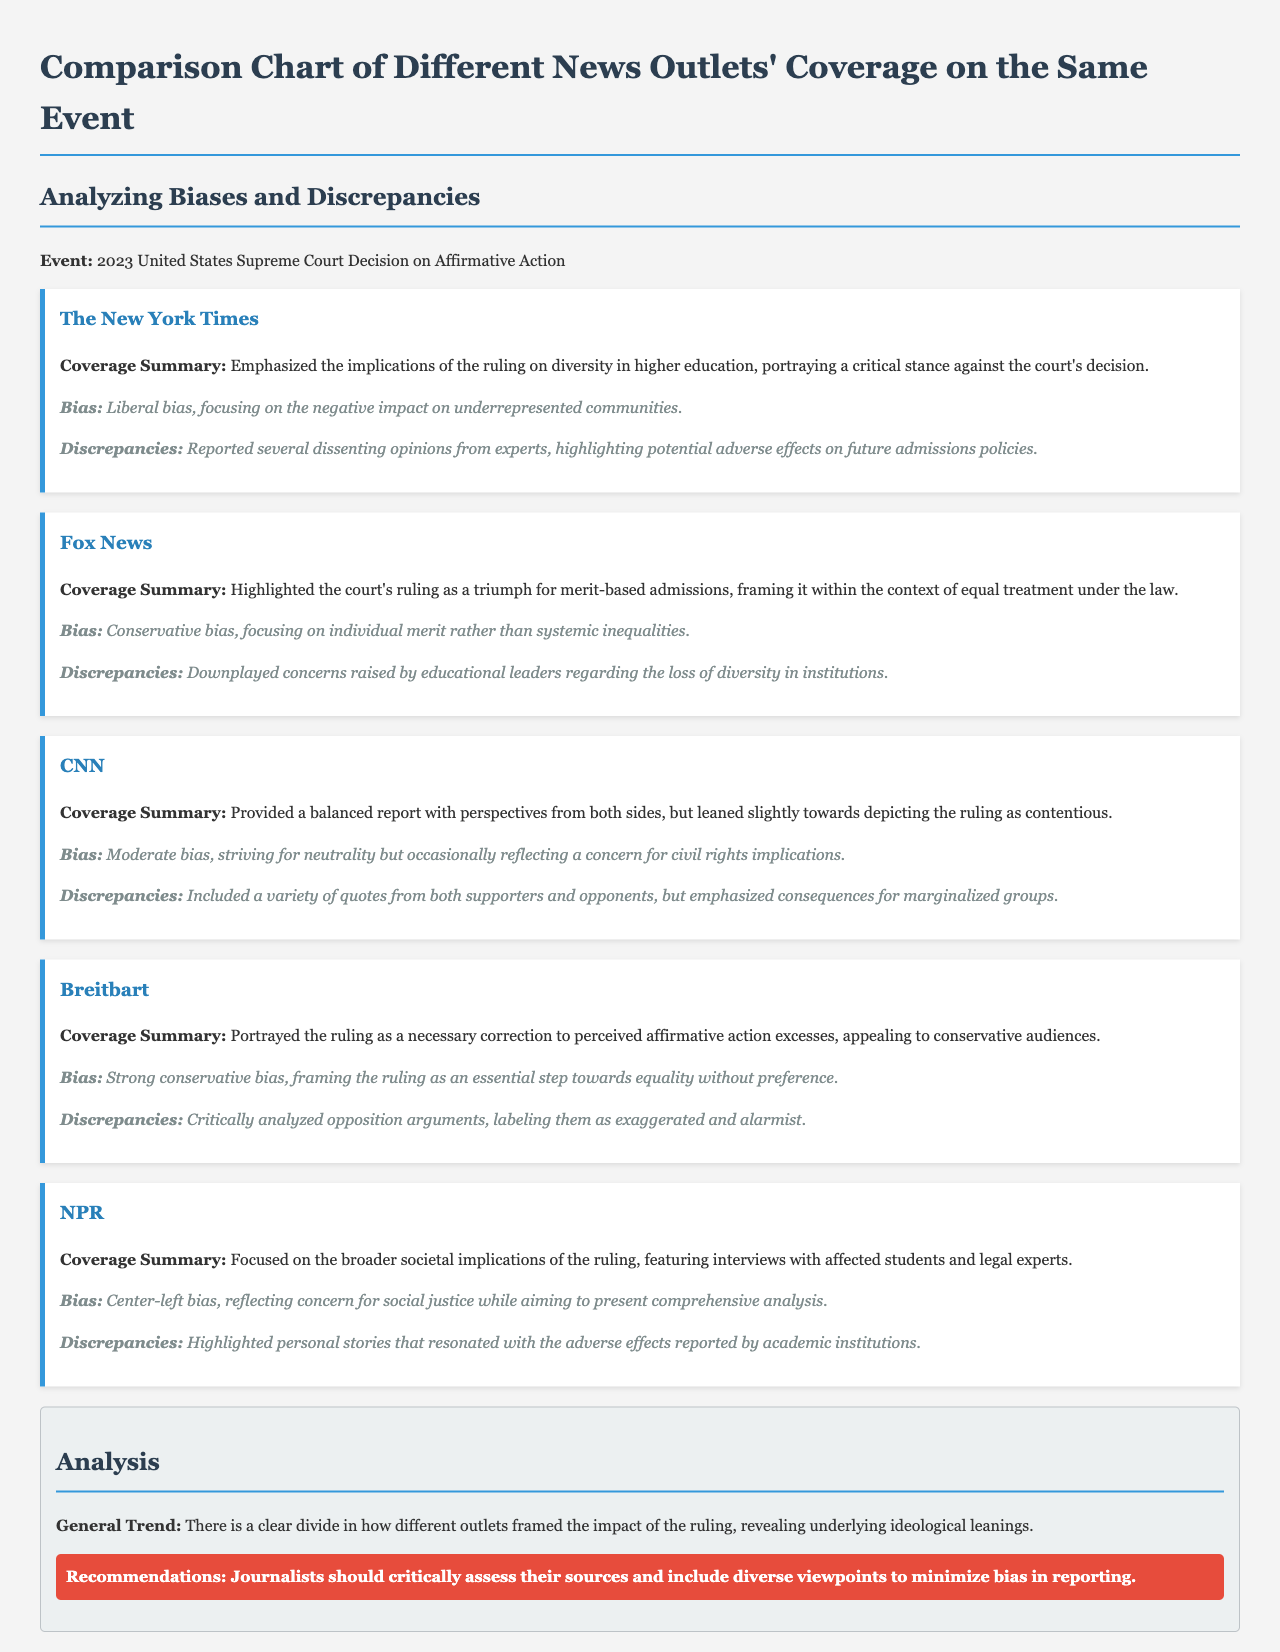What was the event covered in the document? The document discusses the 2023 United States Supreme Court decision on affirmative action, which is the central focus.
Answer: 2023 United States Supreme Court Decision on Affirmative Action Which outlet emphasized the implications of the ruling on diversity in higher education? The New York Times focused on the implications of the ruling, portraying a critical stance against the decision.
Answer: The New York Times What bias is attributed to Fox News in the document? The document describes Fox News as having a conservative bias, focusing on individual merit over systemic inequalities.
Answer: Conservative bias How did CNN's coverage lean according to the document? CNN's coverage is described as balanced but slightly leaning towards depicting the ruling as contentious.
Answer: Slightly towards contentious Which news outlet described the ruling as a necessary correction to affirmative action excesses? Breitbart framed the ruling in this manner, appealing to conservative audiences.
Answer: Breitbart What is recommended for journalists to minimize bias in reporting? The document suggests that journalists should critically assess sources and include diverse viewpoints.
Answer: Critically assess sources and include diverse viewpoints What color is used for headings in the document? The document uses a specific color code for headings that is mentioned in the stylesheet.
Answer: #2c3e50 How many outlets are analyzed in the coverage comparison? The document includes coverage from five different news outlets on the same event.
Answer: Five What type of bias does NPR exhibit according to the manual? NPR is described in the document as having a center-left bias concerning the implications of the ruling.
Answer: Center-left bias 